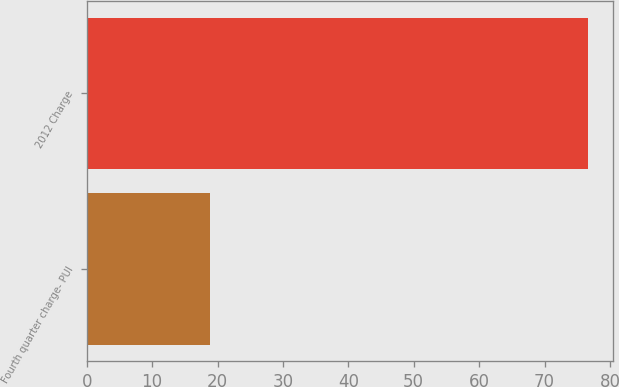<chart> <loc_0><loc_0><loc_500><loc_500><bar_chart><fcel>Fourth quarter charge- PUI<fcel>2012 Charge<nl><fcel>18.8<fcel>76.6<nl></chart> 